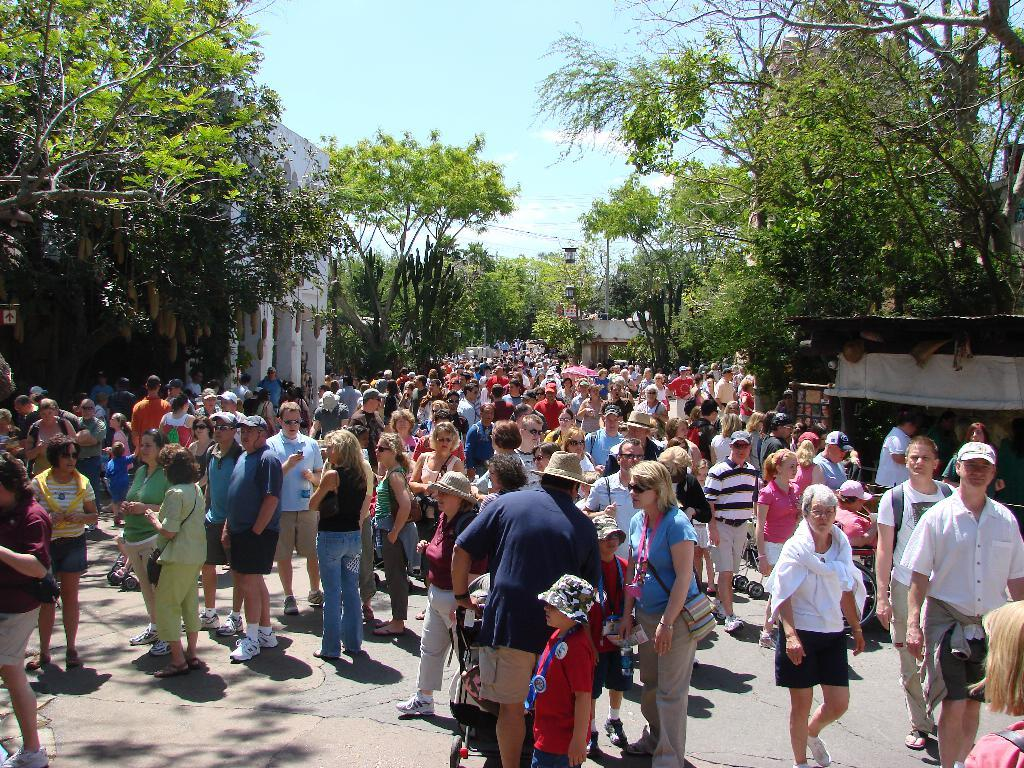What are the people in the image doing? The people in the image are standing and talking to each other. What can be seen in the background of the image? There are trees and the sky visible in the background of the image. What is the condition of the sky in the image? Clouds are present in the sky in the image. What type of design can be seen on the oatmeal in the image? There is no oatmeal present in the image, so there is no design to observe. 